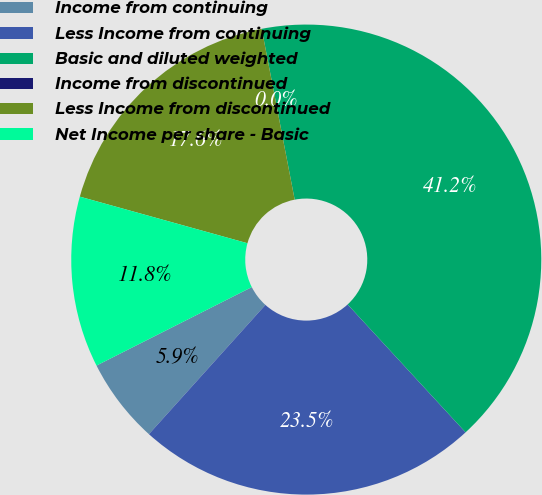Convert chart to OTSL. <chart><loc_0><loc_0><loc_500><loc_500><pie_chart><fcel>Income from continuing<fcel>Less Income from continuing<fcel>Basic and diluted weighted<fcel>Income from discontinued<fcel>Less Income from discontinued<fcel>Net Income per share - Basic<nl><fcel>5.88%<fcel>23.53%<fcel>41.18%<fcel>0.0%<fcel>17.65%<fcel>11.76%<nl></chart> 